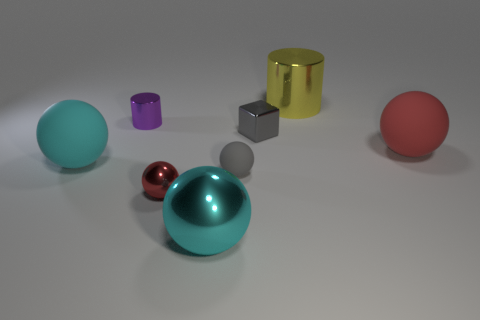Subtract all large red balls. How many balls are left? 4 Subtract all gray spheres. How many spheres are left? 4 Subtract all yellow balls. Subtract all purple cylinders. How many balls are left? 5 Add 2 tiny metal spheres. How many objects exist? 10 Subtract all cylinders. How many objects are left? 6 Add 5 rubber things. How many rubber things exist? 8 Subtract 0 brown spheres. How many objects are left? 8 Subtract all big red metal things. Subtract all large red objects. How many objects are left? 7 Add 6 red rubber things. How many red rubber things are left? 7 